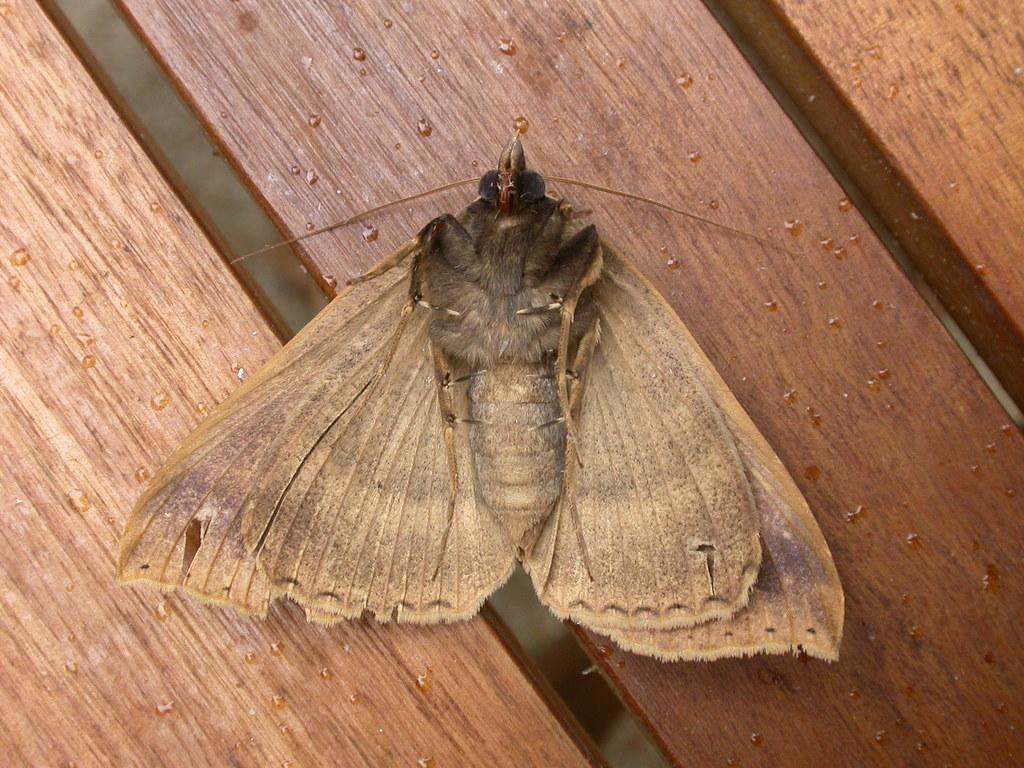Can you describe this image briefly? In this image, this looks like a butterfly on the wooden board. I can see the water boards. 